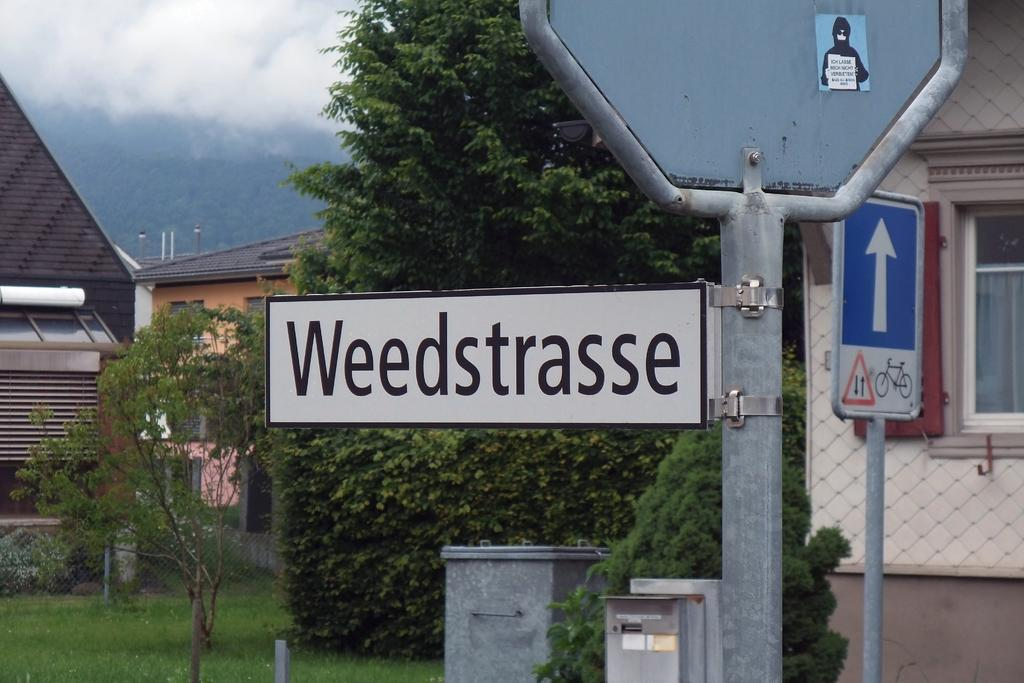What type of objects can be seen in the image with writing or symbols on them? There are sign boards in the image with writing or symbols on them. What can be seen behind the sign boards in the image? Trees and buildings are visible behind the sign boards in the image. What type of surface is visible in the image? There is grass on the surface in the image. What type of electrical infrastructure is present in the image? There are electrical boxes in the image. How does the building in the image react to the earthquake? There is no earthquake present in the image, and therefore no reaction can be observed from the building. 